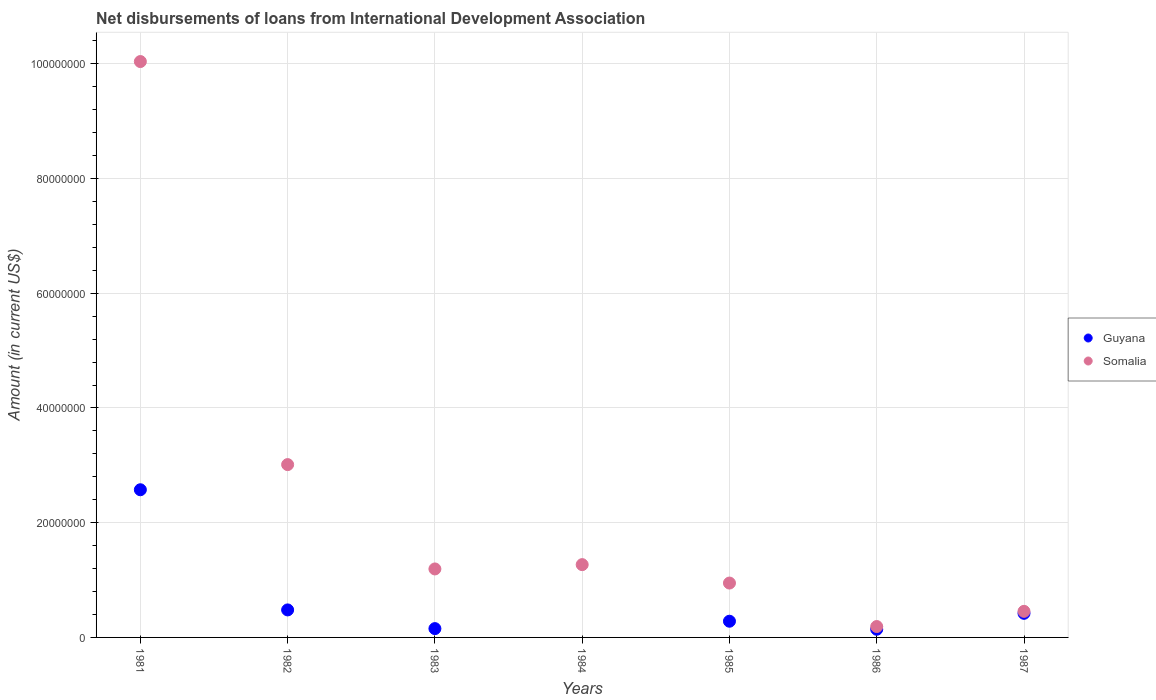What is the amount of loans disbursed in Guyana in 1986?
Provide a succinct answer. 1.42e+06. Across all years, what is the maximum amount of loans disbursed in Somalia?
Keep it short and to the point. 1.00e+08. Across all years, what is the minimum amount of loans disbursed in Somalia?
Your answer should be very brief. 1.90e+06. What is the total amount of loans disbursed in Somalia in the graph?
Offer a terse response. 1.71e+08. What is the difference between the amount of loans disbursed in Somalia in 1983 and that in 1987?
Keep it short and to the point. 7.39e+06. What is the difference between the amount of loans disbursed in Guyana in 1983 and the amount of loans disbursed in Somalia in 1982?
Provide a succinct answer. -2.86e+07. What is the average amount of loans disbursed in Somalia per year?
Give a very brief answer. 2.44e+07. In the year 1981, what is the difference between the amount of loans disbursed in Somalia and amount of loans disbursed in Guyana?
Offer a terse response. 7.46e+07. What is the ratio of the amount of loans disbursed in Somalia in 1983 to that in 1985?
Your response must be concise. 1.26. Is the amount of loans disbursed in Guyana in 1981 less than that in 1982?
Your response must be concise. No. What is the difference between the highest and the second highest amount of loans disbursed in Guyana?
Your response must be concise. 2.09e+07. What is the difference between the highest and the lowest amount of loans disbursed in Somalia?
Make the answer very short. 9.85e+07. Is the sum of the amount of loans disbursed in Somalia in 1982 and 1987 greater than the maximum amount of loans disbursed in Guyana across all years?
Make the answer very short. Yes. Is the amount of loans disbursed in Guyana strictly greater than the amount of loans disbursed in Somalia over the years?
Give a very brief answer. No. What is the difference between two consecutive major ticks on the Y-axis?
Your answer should be very brief. 2.00e+07. Where does the legend appear in the graph?
Give a very brief answer. Center right. What is the title of the graph?
Make the answer very short. Net disbursements of loans from International Development Association. What is the label or title of the X-axis?
Make the answer very short. Years. What is the Amount (in current US$) of Guyana in 1981?
Make the answer very short. 2.57e+07. What is the Amount (in current US$) of Somalia in 1981?
Your response must be concise. 1.00e+08. What is the Amount (in current US$) of Guyana in 1982?
Make the answer very short. 4.80e+06. What is the Amount (in current US$) of Somalia in 1982?
Ensure brevity in your answer.  3.01e+07. What is the Amount (in current US$) of Guyana in 1983?
Ensure brevity in your answer.  1.54e+06. What is the Amount (in current US$) in Somalia in 1983?
Provide a succinct answer. 1.19e+07. What is the Amount (in current US$) of Somalia in 1984?
Offer a very short reply. 1.27e+07. What is the Amount (in current US$) in Guyana in 1985?
Give a very brief answer. 2.82e+06. What is the Amount (in current US$) of Somalia in 1985?
Ensure brevity in your answer.  9.48e+06. What is the Amount (in current US$) in Guyana in 1986?
Offer a very short reply. 1.42e+06. What is the Amount (in current US$) in Somalia in 1986?
Ensure brevity in your answer.  1.90e+06. What is the Amount (in current US$) in Guyana in 1987?
Offer a terse response. 4.20e+06. What is the Amount (in current US$) in Somalia in 1987?
Your answer should be very brief. 4.55e+06. Across all years, what is the maximum Amount (in current US$) of Guyana?
Your answer should be compact. 2.57e+07. Across all years, what is the maximum Amount (in current US$) in Somalia?
Provide a short and direct response. 1.00e+08. Across all years, what is the minimum Amount (in current US$) in Guyana?
Provide a short and direct response. 0. Across all years, what is the minimum Amount (in current US$) of Somalia?
Offer a very short reply. 1.90e+06. What is the total Amount (in current US$) of Guyana in the graph?
Your answer should be compact. 4.05e+07. What is the total Amount (in current US$) of Somalia in the graph?
Offer a terse response. 1.71e+08. What is the difference between the Amount (in current US$) in Guyana in 1981 and that in 1982?
Your answer should be very brief. 2.09e+07. What is the difference between the Amount (in current US$) of Somalia in 1981 and that in 1982?
Keep it short and to the point. 7.03e+07. What is the difference between the Amount (in current US$) in Guyana in 1981 and that in 1983?
Make the answer very short. 2.42e+07. What is the difference between the Amount (in current US$) in Somalia in 1981 and that in 1983?
Your answer should be compact. 8.84e+07. What is the difference between the Amount (in current US$) of Somalia in 1981 and that in 1984?
Make the answer very short. 8.77e+07. What is the difference between the Amount (in current US$) in Guyana in 1981 and that in 1985?
Your response must be concise. 2.29e+07. What is the difference between the Amount (in current US$) in Somalia in 1981 and that in 1985?
Make the answer very short. 9.09e+07. What is the difference between the Amount (in current US$) in Guyana in 1981 and that in 1986?
Your answer should be compact. 2.43e+07. What is the difference between the Amount (in current US$) in Somalia in 1981 and that in 1986?
Your answer should be compact. 9.85e+07. What is the difference between the Amount (in current US$) of Guyana in 1981 and that in 1987?
Provide a succinct answer. 2.15e+07. What is the difference between the Amount (in current US$) in Somalia in 1981 and that in 1987?
Offer a very short reply. 9.58e+07. What is the difference between the Amount (in current US$) of Guyana in 1982 and that in 1983?
Your response must be concise. 3.26e+06. What is the difference between the Amount (in current US$) of Somalia in 1982 and that in 1983?
Your answer should be very brief. 1.82e+07. What is the difference between the Amount (in current US$) of Somalia in 1982 and that in 1984?
Offer a very short reply. 1.74e+07. What is the difference between the Amount (in current US$) of Guyana in 1982 and that in 1985?
Provide a short and direct response. 1.97e+06. What is the difference between the Amount (in current US$) in Somalia in 1982 and that in 1985?
Offer a terse response. 2.06e+07. What is the difference between the Amount (in current US$) of Guyana in 1982 and that in 1986?
Give a very brief answer. 3.37e+06. What is the difference between the Amount (in current US$) of Somalia in 1982 and that in 1986?
Provide a succinct answer. 2.82e+07. What is the difference between the Amount (in current US$) of Guyana in 1982 and that in 1987?
Provide a short and direct response. 5.93e+05. What is the difference between the Amount (in current US$) of Somalia in 1982 and that in 1987?
Your answer should be very brief. 2.56e+07. What is the difference between the Amount (in current US$) in Somalia in 1983 and that in 1984?
Give a very brief answer. -7.51e+05. What is the difference between the Amount (in current US$) of Guyana in 1983 and that in 1985?
Offer a terse response. -1.29e+06. What is the difference between the Amount (in current US$) of Somalia in 1983 and that in 1985?
Your answer should be very brief. 2.46e+06. What is the difference between the Amount (in current US$) in Guyana in 1983 and that in 1986?
Provide a short and direct response. 1.14e+05. What is the difference between the Amount (in current US$) in Somalia in 1983 and that in 1986?
Keep it short and to the point. 1.00e+07. What is the difference between the Amount (in current US$) in Guyana in 1983 and that in 1987?
Your answer should be very brief. -2.67e+06. What is the difference between the Amount (in current US$) in Somalia in 1983 and that in 1987?
Ensure brevity in your answer.  7.39e+06. What is the difference between the Amount (in current US$) of Somalia in 1984 and that in 1985?
Make the answer very short. 3.21e+06. What is the difference between the Amount (in current US$) of Somalia in 1984 and that in 1986?
Your response must be concise. 1.08e+07. What is the difference between the Amount (in current US$) of Somalia in 1984 and that in 1987?
Offer a very short reply. 8.14e+06. What is the difference between the Amount (in current US$) of Guyana in 1985 and that in 1986?
Provide a succinct answer. 1.40e+06. What is the difference between the Amount (in current US$) of Somalia in 1985 and that in 1986?
Your answer should be very brief. 7.58e+06. What is the difference between the Amount (in current US$) of Guyana in 1985 and that in 1987?
Your response must be concise. -1.38e+06. What is the difference between the Amount (in current US$) of Somalia in 1985 and that in 1987?
Your response must be concise. 4.93e+06. What is the difference between the Amount (in current US$) in Guyana in 1986 and that in 1987?
Your answer should be compact. -2.78e+06. What is the difference between the Amount (in current US$) in Somalia in 1986 and that in 1987?
Make the answer very short. -2.65e+06. What is the difference between the Amount (in current US$) of Guyana in 1981 and the Amount (in current US$) of Somalia in 1982?
Offer a very short reply. -4.38e+06. What is the difference between the Amount (in current US$) in Guyana in 1981 and the Amount (in current US$) in Somalia in 1983?
Ensure brevity in your answer.  1.38e+07. What is the difference between the Amount (in current US$) in Guyana in 1981 and the Amount (in current US$) in Somalia in 1984?
Your answer should be compact. 1.31e+07. What is the difference between the Amount (in current US$) in Guyana in 1981 and the Amount (in current US$) in Somalia in 1985?
Make the answer very short. 1.63e+07. What is the difference between the Amount (in current US$) in Guyana in 1981 and the Amount (in current US$) in Somalia in 1986?
Offer a terse response. 2.38e+07. What is the difference between the Amount (in current US$) of Guyana in 1981 and the Amount (in current US$) of Somalia in 1987?
Offer a very short reply. 2.12e+07. What is the difference between the Amount (in current US$) in Guyana in 1982 and the Amount (in current US$) in Somalia in 1983?
Offer a terse response. -7.14e+06. What is the difference between the Amount (in current US$) of Guyana in 1982 and the Amount (in current US$) of Somalia in 1984?
Your response must be concise. -7.89e+06. What is the difference between the Amount (in current US$) of Guyana in 1982 and the Amount (in current US$) of Somalia in 1985?
Make the answer very short. -4.68e+06. What is the difference between the Amount (in current US$) in Guyana in 1982 and the Amount (in current US$) in Somalia in 1986?
Your answer should be compact. 2.90e+06. What is the difference between the Amount (in current US$) of Guyana in 1982 and the Amount (in current US$) of Somalia in 1987?
Your answer should be compact. 2.50e+05. What is the difference between the Amount (in current US$) in Guyana in 1983 and the Amount (in current US$) in Somalia in 1984?
Ensure brevity in your answer.  -1.12e+07. What is the difference between the Amount (in current US$) in Guyana in 1983 and the Amount (in current US$) in Somalia in 1985?
Your answer should be very brief. -7.94e+06. What is the difference between the Amount (in current US$) in Guyana in 1983 and the Amount (in current US$) in Somalia in 1986?
Give a very brief answer. -3.62e+05. What is the difference between the Amount (in current US$) of Guyana in 1983 and the Amount (in current US$) of Somalia in 1987?
Ensure brevity in your answer.  -3.01e+06. What is the difference between the Amount (in current US$) of Guyana in 1985 and the Amount (in current US$) of Somalia in 1986?
Offer a terse response. 9.25e+05. What is the difference between the Amount (in current US$) of Guyana in 1985 and the Amount (in current US$) of Somalia in 1987?
Your answer should be very brief. -1.72e+06. What is the difference between the Amount (in current US$) in Guyana in 1986 and the Amount (in current US$) in Somalia in 1987?
Ensure brevity in your answer.  -3.12e+06. What is the average Amount (in current US$) in Guyana per year?
Your response must be concise. 5.79e+06. What is the average Amount (in current US$) in Somalia per year?
Offer a very short reply. 2.44e+07. In the year 1981, what is the difference between the Amount (in current US$) in Guyana and Amount (in current US$) in Somalia?
Your answer should be very brief. -7.46e+07. In the year 1982, what is the difference between the Amount (in current US$) in Guyana and Amount (in current US$) in Somalia?
Provide a short and direct response. -2.53e+07. In the year 1983, what is the difference between the Amount (in current US$) of Guyana and Amount (in current US$) of Somalia?
Ensure brevity in your answer.  -1.04e+07. In the year 1985, what is the difference between the Amount (in current US$) in Guyana and Amount (in current US$) in Somalia?
Keep it short and to the point. -6.65e+06. In the year 1986, what is the difference between the Amount (in current US$) of Guyana and Amount (in current US$) of Somalia?
Give a very brief answer. -4.76e+05. In the year 1987, what is the difference between the Amount (in current US$) of Guyana and Amount (in current US$) of Somalia?
Provide a succinct answer. -3.43e+05. What is the ratio of the Amount (in current US$) of Guyana in 1981 to that in 1982?
Offer a terse response. 5.37. What is the ratio of the Amount (in current US$) of Somalia in 1981 to that in 1982?
Provide a short and direct response. 3.33. What is the ratio of the Amount (in current US$) of Guyana in 1981 to that in 1983?
Your response must be concise. 16.75. What is the ratio of the Amount (in current US$) of Somalia in 1981 to that in 1983?
Make the answer very short. 8.41. What is the ratio of the Amount (in current US$) of Somalia in 1981 to that in 1984?
Make the answer very short. 7.91. What is the ratio of the Amount (in current US$) in Guyana in 1981 to that in 1985?
Ensure brevity in your answer.  9.12. What is the ratio of the Amount (in current US$) of Somalia in 1981 to that in 1985?
Ensure brevity in your answer.  10.59. What is the ratio of the Amount (in current US$) in Guyana in 1981 to that in 1986?
Offer a terse response. 18.09. What is the ratio of the Amount (in current US$) of Somalia in 1981 to that in 1986?
Your answer should be very brief. 52.86. What is the ratio of the Amount (in current US$) of Guyana in 1981 to that in 1987?
Offer a terse response. 6.12. What is the ratio of the Amount (in current US$) of Somalia in 1981 to that in 1987?
Offer a very short reply. 22.08. What is the ratio of the Amount (in current US$) in Guyana in 1982 to that in 1983?
Your answer should be very brief. 3.12. What is the ratio of the Amount (in current US$) in Somalia in 1982 to that in 1983?
Offer a terse response. 2.52. What is the ratio of the Amount (in current US$) in Somalia in 1982 to that in 1984?
Your response must be concise. 2.37. What is the ratio of the Amount (in current US$) in Guyana in 1982 to that in 1985?
Provide a short and direct response. 1.7. What is the ratio of the Amount (in current US$) of Somalia in 1982 to that in 1985?
Offer a terse response. 3.18. What is the ratio of the Amount (in current US$) in Guyana in 1982 to that in 1986?
Your response must be concise. 3.37. What is the ratio of the Amount (in current US$) of Somalia in 1982 to that in 1986?
Your answer should be compact. 15.86. What is the ratio of the Amount (in current US$) in Guyana in 1982 to that in 1987?
Your answer should be compact. 1.14. What is the ratio of the Amount (in current US$) in Somalia in 1982 to that in 1987?
Make the answer very short. 6.63. What is the ratio of the Amount (in current US$) of Somalia in 1983 to that in 1984?
Provide a succinct answer. 0.94. What is the ratio of the Amount (in current US$) of Guyana in 1983 to that in 1985?
Your response must be concise. 0.54. What is the ratio of the Amount (in current US$) in Somalia in 1983 to that in 1985?
Your answer should be compact. 1.26. What is the ratio of the Amount (in current US$) of Guyana in 1983 to that in 1986?
Your response must be concise. 1.08. What is the ratio of the Amount (in current US$) of Somalia in 1983 to that in 1986?
Keep it short and to the point. 6.29. What is the ratio of the Amount (in current US$) of Guyana in 1983 to that in 1987?
Your response must be concise. 0.37. What is the ratio of the Amount (in current US$) in Somalia in 1983 to that in 1987?
Offer a very short reply. 2.63. What is the ratio of the Amount (in current US$) in Somalia in 1984 to that in 1985?
Give a very brief answer. 1.34. What is the ratio of the Amount (in current US$) of Somalia in 1984 to that in 1986?
Make the answer very short. 6.68. What is the ratio of the Amount (in current US$) of Somalia in 1984 to that in 1987?
Provide a short and direct response. 2.79. What is the ratio of the Amount (in current US$) of Guyana in 1985 to that in 1986?
Your response must be concise. 1.98. What is the ratio of the Amount (in current US$) in Somalia in 1985 to that in 1986?
Keep it short and to the point. 4.99. What is the ratio of the Amount (in current US$) in Guyana in 1985 to that in 1987?
Make the answer very short. 0.67. What is the ratio of the Amount (in current US$) in Somalia in 1985 to that in 1987?
Your response must be concise. 2.08. What is the ratio of the Amount (in current US$) in Guyana in 1986 to that in 1987?
Offer a very short reply. 0.34. What is the ratio of the Amount (in current US$) of Somalia in 1986 to that in 1987?
Offer a terse response. 0.42. What is the difference between the highest and the second highest Amount (in current US$) in Guyana?
Your answer should be compact. 2.09e+07. What is the difference between the highest and the second highest Amount (in current US$) of Somalia?
Keep it short and to the point. 7.03e+07. What is the difference between the highest and the lowest Amount (in current US$) in Guyana?
Ensure brevity in your answer.  2.57e+07. What is the difference between the highest and the lowest Amount (in current US$) in Somalia?
Keep it short and to the point. 9.85e+07. 